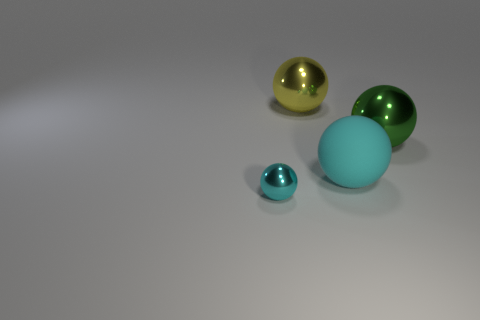Add 4 gray cylinders. How many objects exist? 8 Add 2 green balls. How many green balls exist? 3 Subtract 0 red balls. How many objects are left? 4 Subtract all cyan rubber things. Subtract all small cyan balls. How many objects are left? 2 Add 3 large green metallic spheres. How many large green metallic spheres are left? 4 